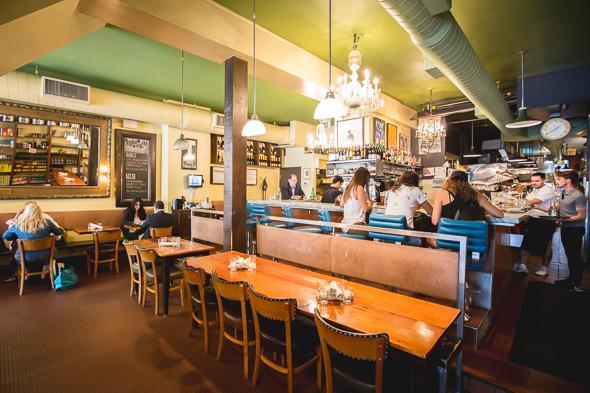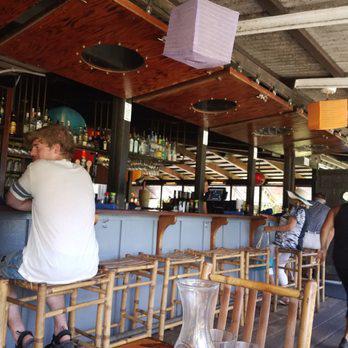The first image is the image on the left, the second image is the image on the right. Examine the images to the left and right. Is the description "The room in the right image has no people in it." accurate? Answer yes or no. No. The first image is the image on the left, the second image is the image on the right. Assess this claim about the two images: "Dome-shaped lights in rows suspend several feet from the ceiling over multiple seated customers in the left image.". Correct or not? Answer yes or no. Yes. 